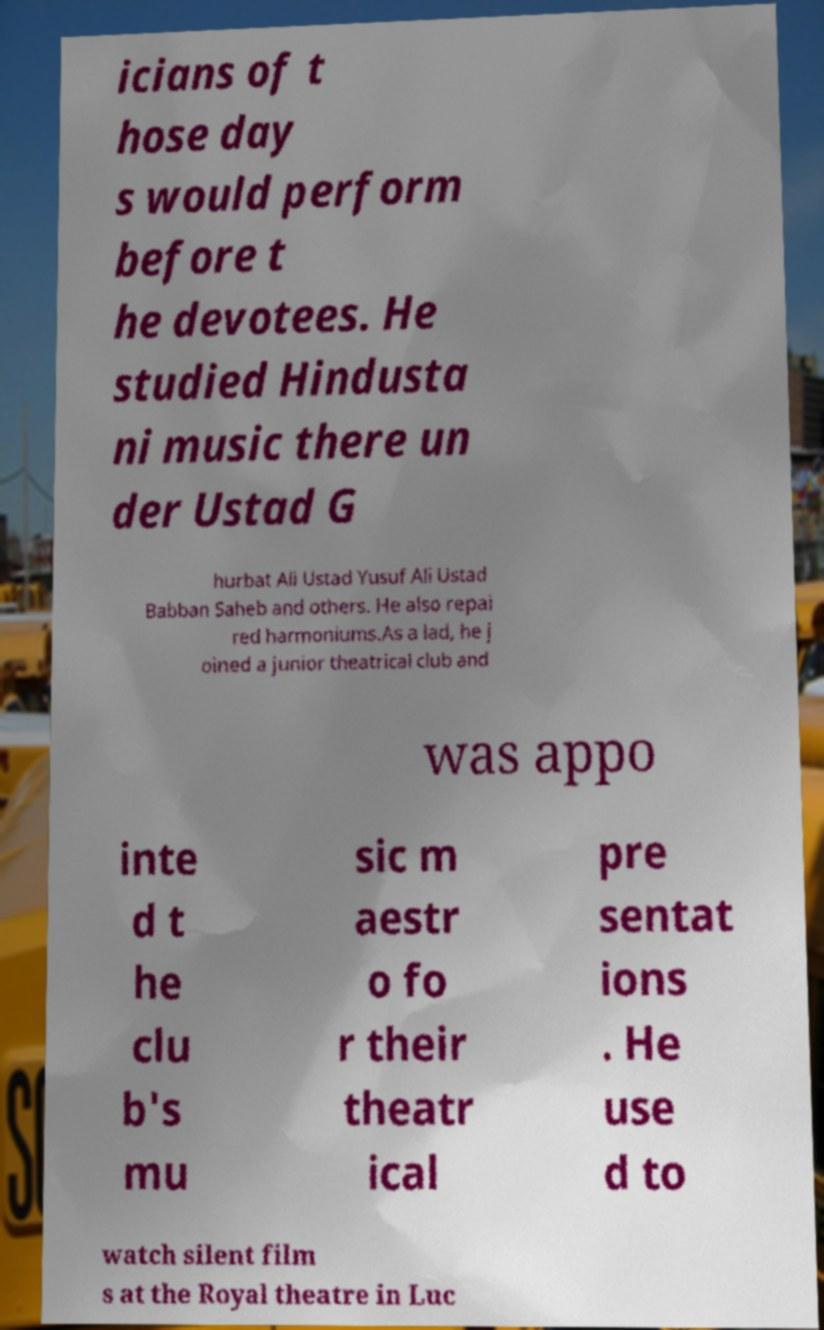Can you read and provide the text displayed in the image?This photo seems to have some interesting text. Can you extract and type it out for me? icians of t hose day s would perform before t he devotees. He studied Hindusta ni music there un der Ustad G hurbat Ali Ustad Yusuf Ali Ustad Babban Saheb and others. He also repai red harmoniums.As a lad, he j oined a junior theatrical club and was appo inte d t he clu b's mu sic m aestr o fo r their theatr ical pre sentat ions . He use d to watch silent film s at the Royal theatre in Luc 